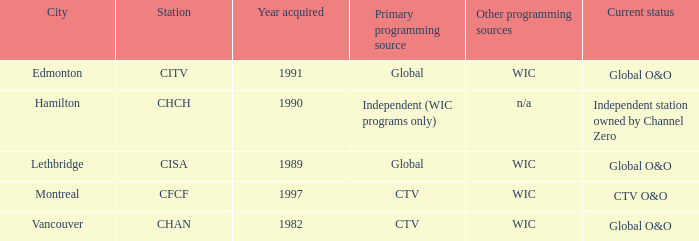What station is positioned in edmonton? CITV. Give me the full table as a dictionary. {'header': ['City', 'Station', 'Year acquired', 'Primary programming source', 'Other programming sources', 'Current status'], 'rows': [['Edmonton', 'CITV', '1991', 'Global', 'WIC', 'Global O&O'], ['Hamilton', 'CHCH', '1990', 'Independent (WIC programs only)', 'n/a', 'Independent station owned by Channel Zero'], ['Lethbridge', 'CISA', '1989', 'Global', 'WIC', 'Global O&O'], ['Montreal', 'CFCF', '1997', 'CTV', 'WIC', 'CTV O&O'], ['Vancouver', 'CHAN', '1982', 'CTV', 'WIC', 'Global O&O']]} 